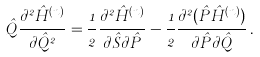Convert formula to latex. <formula><loc_0><loc_0><loc_500><loc_500>{ \hat { Q } } \frac { \partial ^ { 2 } { \hat { H } } ^ { ( n ) } } { \partial { \hat { Q } } ^ { 2 } } = \frac { 1 } { 2 } \frac { \partial ^ { 2 } { \hat { H } } ^ { ( n ) } } { \partial { \hat { S } } \partial { \hat { P } } } - \frac { 1 } { 2 } \frac { \partial ^ { 2 } ( { \hat { P } } { \hat { H } } ^ { ( n ) } ) } { \partial { \hat { P } } \partial { \hat { Q } } } \, .</formula> 